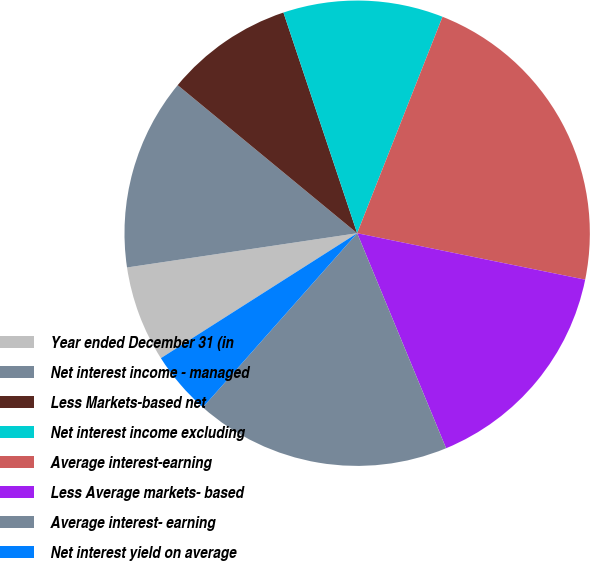Convert chart to OTSL. <chart><loc_0><loc_0><loc_500><loc_500><pie_chart><fcel>Year ended December 31 (in<fcel>Net interest income - managed<fcel>Less Markets-based net<fcel>Net interest income excluding<fcel>Average interest-earning<fcel>Less Average markets- based<fcel>Average interest- earning<fcel>Net interest yield on average<nl><fcel>6.67%<fcel>13.33%<fcel>8.89%<fcel>11.11%<fcel>22.22%<fcel>15.56%<fcel>17.78%<fcel>4.44%<nl></chart> 